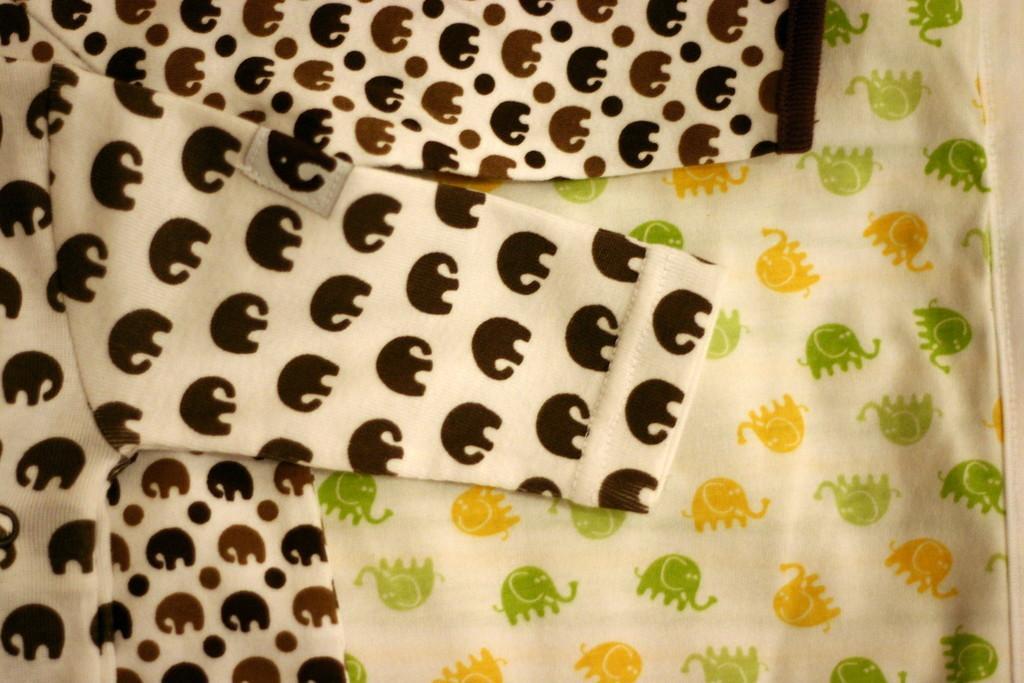Please provide a concise description of this image. In this picture we can see clothes with paintings on it. 